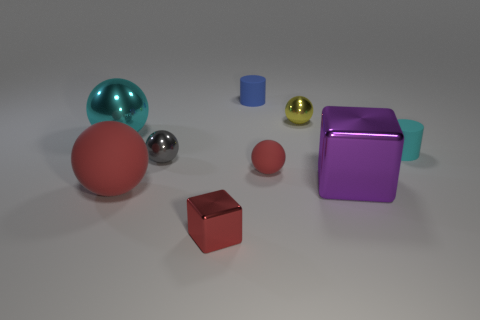What is the material of the cylinder that is in front of the large sphere behind the small cylinder that is in front of the small yellow ball?
Give a very brief answer. Rubber. Are there any other things that have the same size as the blue matte cylinder?
Provide a short and direct response. Yes. How many matte objects are either big balls or red spheres?
Offer a very short reply. 2. Are there any red rubber things?
Your answer should be very brief. Yes. There is a ball behind the ball that is on the left side of the big matte object; what color is it?
Give a very brief answer. Yellow. How many other objects are the same color as the big block?
Offer a very short reply. 0. What number of things are large red matte balls or matte objects that are behind the cyan rubber cylinder?
Give a very brief answer. 2. The matte cylinder that is behind the large cyan shiny sphere is what color?
Your answer should be compact. Blue. The tiny red matte object has what shape?
Offer a very short reply. Sphere. There is a tiny yellow thing in front of the small rubber cylinder that is on the left side of the large purple thing; what is its material?
Your answer should be compact. Metal. 